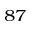<formula> <loc_0><loc_0><loc_500><loc_500>^ { 8 7 }</formula> 